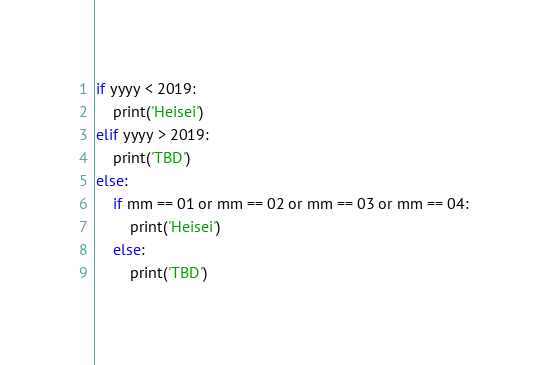<code> <loc_0><loc_0><loc_500><loc_500><_Python_>if yyyy < 2019:
    print('Heisei')
elif yyyy > 2019:
    print('TBD')
else:
    if mm == 01 or mm == 02 or mm == 03 or mm == 04:
        print('Heisei')
    else:
        print('TBD')</code> 